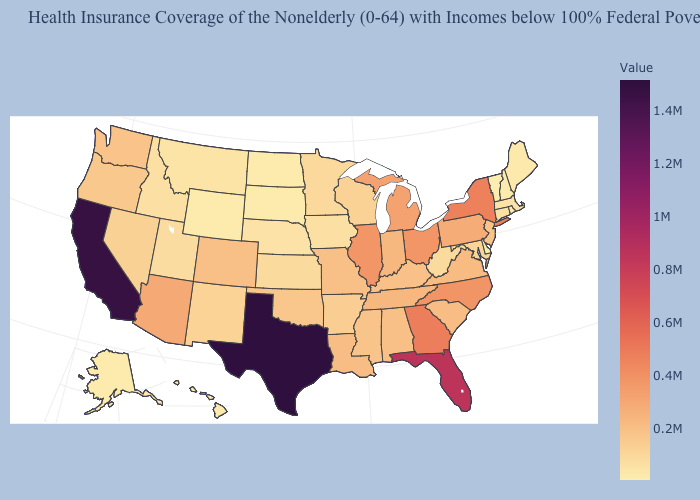Does Oregon have the highest value in the West?
Give a very brief answer. No. Does Massachusetts have the lowest value in the Northeast?
Concise answer only. No. Which states have the highest value in the USA?
Keep it brief. Texas. Which states have the lowest value in the MidWest?
Be succinct. North Dakota. Is the legend a continuous bar?
Write a very short answer. Yes. Which states hav the highest value in the West?
Give a very brief answer. California. Does Washington have the highest value in the USA?
Keep it brief. No. 